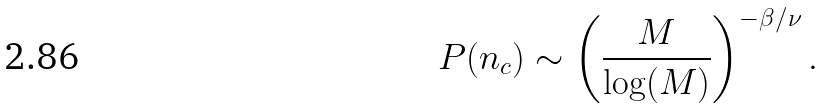Convert formula to latex. <formula><loc_0><loc_0><loc_500><loc_500>P ( n _ { c } ) \sim \left ( \frac { M } { \log ( M ) } \right ) ^ { - \beta / \nu } .</formula> 